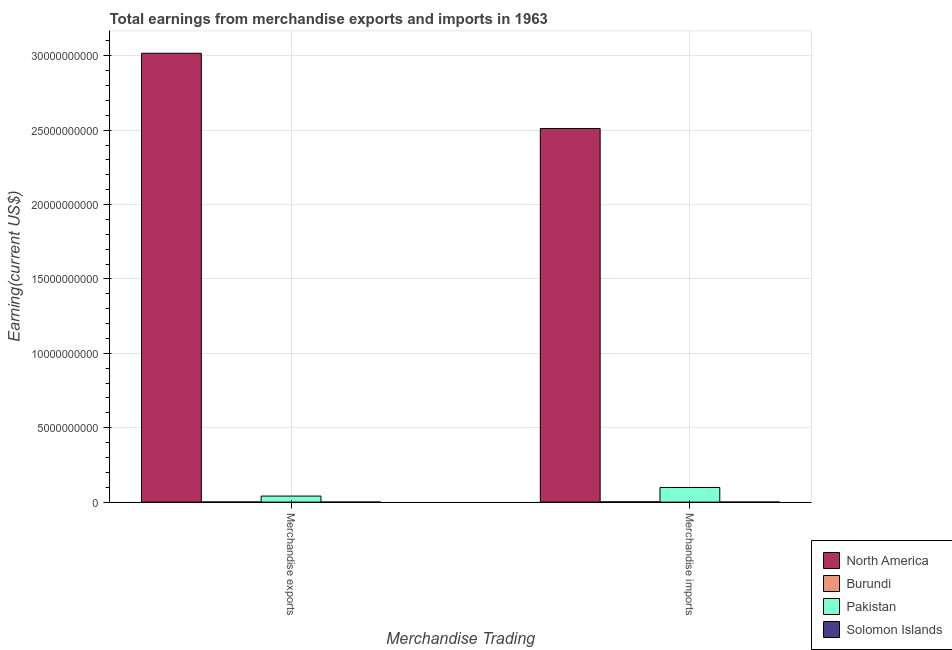How many different coloured bars are there?
Ensure brevity in your answer.  4. How many groups of bars are there?
Give a very brief answer. 2. Are the number of bars on each tick of the X-axis equal?
Ensure brevity in your answer.  Yes. How many bars are there on the 2nd tick from the left?
Your answer should be compact. 4. What is the label of the 2nd group of bars from the left?
Offer a very short reply. Merchandise imports. What is the earnings from merchandise exports in Solomon Islands?
Offer a very short reply. 4.16e+06. Across all countries, what is the maximum earnings from merchandise imports?
Make the answer very short. 2.51e+1. Across all countries, what is the minimum earnings from merchandise imports?
Ensure brevity in your answer.  5.88e+06. In which country was the earnings from merchandise exports maximum?
Make the answer very short. North America. In which country was the earnings from merchandise imports minimum?
Your answer should be very brief. Solomon Islands. What is the total earnings from merchandise imports in the graph?
Offer a terse response. 2.61e+1. What is the difference between the earnings from merchandise imports in Burundi and that in Solomon Islands?
Make the answer very short. 1.24e+07. What is the difference between the earnings from merchandise imports in Pakistan and the earnings from merchandise exports in North America?
Your answer should be very brief. -2.92e+1. What is the average earnings from merchandise exports per country?
Ensure brevity in your answer.  7.65e+09. What is the difference between the earnings from merchandise exports and earnings from merchandise imports in Solomon Islands?
Your answer should be compact. -1.72e+06. In how many countries, is the earnings from merchandise imports greater than 29000000000 US$?
Make the answer very short. 0. What is the ratio of the earnings from merchandise exports in North America to that in Burundi?
Your answer should be very brief. 3351.98. Is the earnings from merchandise exports in Pakistan less than that in Burundi?
Keep it short and to the point. No. In how many countries, is the earnings from merchandise exports greater than the average earnings from merchandise exports taken over all countries?
Ensure brevity in your answer.  1. What does the 3rd bar from the left in Merchandise exports represents?
Offer a terse response. Pakistan. What does the 3rd bar from the right in Merchandise imports represents?
Provide a succinct answer. Burundi. How many bars are there?
Your response must be concise. 8. Are all the bars in the graph horizontal?
Your answer should be very brief. No. How many countries are there in the graph?
Your answer should be compact. 4. What is the difference between two consecutive major ticks on the Y-axis?
Provide a short and direct response. 5.00e+09. Are the values on the major ticks of Y-axis written in scientific E-notation?
Keep it short and to the point. No. Does the graph contain any zero values?
Offer a terse response. No. How many legend labels are there?
Give a very brief answer. 4. What is the title of the graph?
Make the answer very short. Total earnings from merchandise exports and imports in 1963. What is the label or title of the X-axis?
Give a very brief answer. Merchandise Trading. What is the label or title of the Y-axis?
Your response must be concise. Earning(current US$). What is the Earning(current US$) in North America in Merchandise exports?
Your response must be concise. 3.02e+1. What is the Earning(current US$) in Burundi in Merchandise exports?
Your answer should be very brief. 9.00e+06. What is the Earning(current US$) in Pakistan in Merchandise exports?
Provide a succinct answer. 4.07e+08. What is the Earning(current US$) of Solomon Islands in Merchandise exports?
Your answer should be very brief. 4.16e+06. What is the Earning(current US$) of North America in Merchandise imports?
Give a very brief answer. 2.51e+1. What is the Earning(current US$) of Burundi in Merchandise imports?
Provide a succinct answer. 1.83e+07. What is the Earning(current US$) in Pakistan in Merchandise imports?
Keep it short and to the point. 9.85e+08. What is the Earning(current US$) of Solomon Islands in Merchandise imports?
Your answer should be very brief. 5.88e+06. Across all Merchandise Trading, what is the maximum Earning(current US$) of North America?
Offer a terse response. 3.02e+1. Across all Merchandise Trading, what is the maximum Earning(current US$) in Burundi?
Ensure brevity in your answer.  1.83e+07. Across all Merchandise Trading, what is the maximum Earning(current US$) of Pakistan?
Offer a terse response. 9.85e+08. Across all Merchandise Trading, what is the maximum Earning(current US$) in Solomon Islands?
Provide a short and direct response. 5.88e+06. Across all Merchandise Trading, what is the minimum Earning(current US$) of North America?
Keep it short and to the point. 2.51e+1. Across all Merchandise Trading, what is the minimum Earning(current US$) of Burundi?
Your answer should be compact. 9.00e+06. Across all Merchandise Trading, what is the minimum Earning(current US$) of Pakistan?
Ensure brevity in your answer.  4.07e+08. Across all Merchandise Trading, what is the minimum Earning(current US$) of Solomon Islands?
Provide a succinct answer. 4.16e+06. What is the total Earning(current US$) of North America in the graph?
Ensure brevity in your answer.  5.53e+1. What is the total Earning(current US$) of Burundi in the graph?
Provide a succinct answer. 2.73e+07. What is the total Earning(current US$) in Pakistan in the graph?
Provide a short and direct response. 1.39e+09. What is the total Earning(current US$) of Solomon Islands in the graph?
Ensure brevity in your answer.  1.00e+07. What is the difference between the Earning(current US$) in North America in Merchandise exports and that in Merchandise imports?
Your answer should be compact. 5.06e+09. What is the difference between the Earning(current US$) of Burundi in Merchandise exports and that in Merchandise imports?
Your response must be concise. -9.32e+06. What is the difference between the Earning(current US$) of Pakistan in Merchandise exports and that in Merchandise imports?
Offer a terse response. -5.78e+08. What is the difference between the Earning(current US$) in Solomon Islands in Merchandise exports and that in Merchandise imports?
Your answer should be very brief. -1.72e+06. What is the difference between the Earning(current US$) of North America in Merchandise exports and the Earning(current US$) of Burundi in Merchandise imports?
Your response must be concise. 3.01e+1. What is the difference between the Earning(current US$) of North America in Merchandise exports and the Earning(current US$) of Pakistan in Merchandise imports?
Make the answer very short. 2.92e+1. What is the difference between the Earning(current US$) of North America in Merchandise exports and the Earning(current US$) of Solomon Islands in Merchandise imports?
Provide a succinct answer. 3.02e+1. What is the difference between the Earning(current US$) of Burundi in Merchandise exports and the Earning(current US$) of Pakistan in Merchandise imports?
Keep it short and to the point. -9.76e+08. What is the difference between the Earning(current US$) in Burundi in Merchandise exports and the Earning(current US$) in Solomon Islands in Merchandise imports?
Offer a terse response. 3.12e+06. What is the difference between the Earning(current US$) of Pakistan in Merchandise exports and the Earning(current US$) of Solomon Islands in Merchandise imports?
Your answer should be compact. 4.01e+08. What is the average Earning(current US$) in North America per Merchandise Trading?
Give a very brief answer. 2.76e+1. What is the average Earning(current US$) in Burundi per Merchandise Trading?
Your answer should be very brief. 1.37e+07. What is the average Earning(current US$) of Pakistan per Merchandise Trading?
Offer a very short reply. 6.96e+08. What is the average Earning(current US$) in Solomon Islands per Merchandise Trading?
Keep it short and to the point. 5.02e+06. What is the difference between the Earning(current US$) in North America and Earning(current US$) in Burundi in Merchandise exports?
Provide a succinct answer. 3.02e+1. What is the difference between the Earning(current US$) in North America and Earning(current US$) in Pakistan in Merchandise exports?
Ensure brevity in your answer.  2.98e+1. What is the difference between the Earning(current US$) in North America and Earning(current US$) in Solomon Islands in Merchandise exports?
Provide a succinct answer. 3.02e+1. What is the difference between the Earning(current US$) of Burundi and Earning(current US$) of Pakistan in Merchandise exports?
Provide a succinct answer. -3.98e+08. What is the difference between the Earning(current US$) of Burundi and Earning(current US$) of Solomon Islands in Merchandise exports?
Your answer should be very brief. 4.84e+06. What is the difference between the Earning(current US$) of Pakistan and Earning(current US$) of Solomon Islands in Merchandise exports?
Offer a terse response. 4.02e+08. What is the difference between the Earning(current US$) in North America and Earning(current US$) in Burundi in Merchandise imports?
Provide a succinct answer. 2.51e+1. What is the difference between the Earning(current US$) in North America and Earning(current US$) in Pakistan in Merchandise imports?
Give a very brief answer. 2.41e+1. What is the difference between the Earning(current US$) of North America and Earning(current US$) of Solomon Islands in Merchandise imports?
Make the answer very short. 2.51e+1. What is the difference between the Earning(current US$) of Burundi and Earning(current US$) of Pakistan in Merchandise imports?
Keep it short and to the point. -9.67e+08. What is the difference between the Earning(current US$) of Burundi and Earning(current US$) of Solomon Islands in Merchandise imports?
Your response must be concise. 1.24e+07. What is the difference between the Earning(current US$) of Pakistan and Earning(current US$) of Solomon Islands in Merchandise imports?
Your response must be concise. 9.79e+08. What is the ratio of the Earning(current US$) of North America in Merchandise exports to that in Merchandise imports?
Make the answer very short. 1.2. What is the ratio of the Earning(current US$) of Burundi in Merchandise exports to that in Merchandise imports?
Keep it short and to the point. 0.49. What is the ratio of the Earning(current US$) in Pakistan in Merchandise exports to that in Merchandise imports?
Provide a succinct answer. 0.41. What is the ratio of the Earning(current US$) in Solomon Islands in Merchandise exports to that in Merchandise imports?
Your answer should be compact. 0.71. What is the difference between the highest and the second highest Earning(current US$) in North America?
Ensure brevity in your answer.  5.06e+09. What is the difference between the highest and the second highest Earning(current US$) of Burundi?
Ensure brevity in your answer.  9.32e+06. What is the difference between the highest and the second highest Earning(current US$) of Pakistan?
Provide a succinct answer. 5.78e+08. What is the difference between the highest and the second highest Earning(current US$) of Solomon Islands?
Provide a short and direct response. 1.72e+06. What is the difference between the highest and the lowest Earning(current US$) of North America?
Make the answer very short. 5.06e+09. What is the difference between the highest and the lowest Earning(current US$) of Burundi?
Give a very brief answer. 9.32e+06. What is the difference between the highest and the lowest Earning(current US$) in Pakistan?
Your answer should be very brief. 5.78e+08. What is the difference between the highest and the lowest Earning(current US$) of Solomon Islands?
Provide a short and direct response. 1.72e+06. 